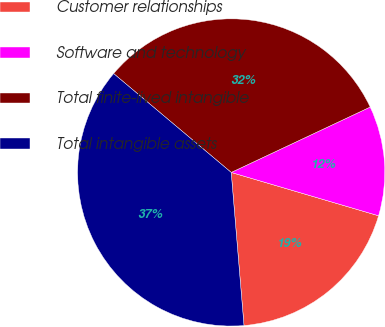Convert chart. <chart><loc_0><loc_0><loc_500><loc_500><pie_chart><fcel>Customer relationships<fcel>Software and technology<fcel>Total finite-lived intangible<fcel>Total intangible assets<nl><fcel>19.12%<fcel>11.55%<fcel>31.87%<fcel>37.45%<nl></chart> 